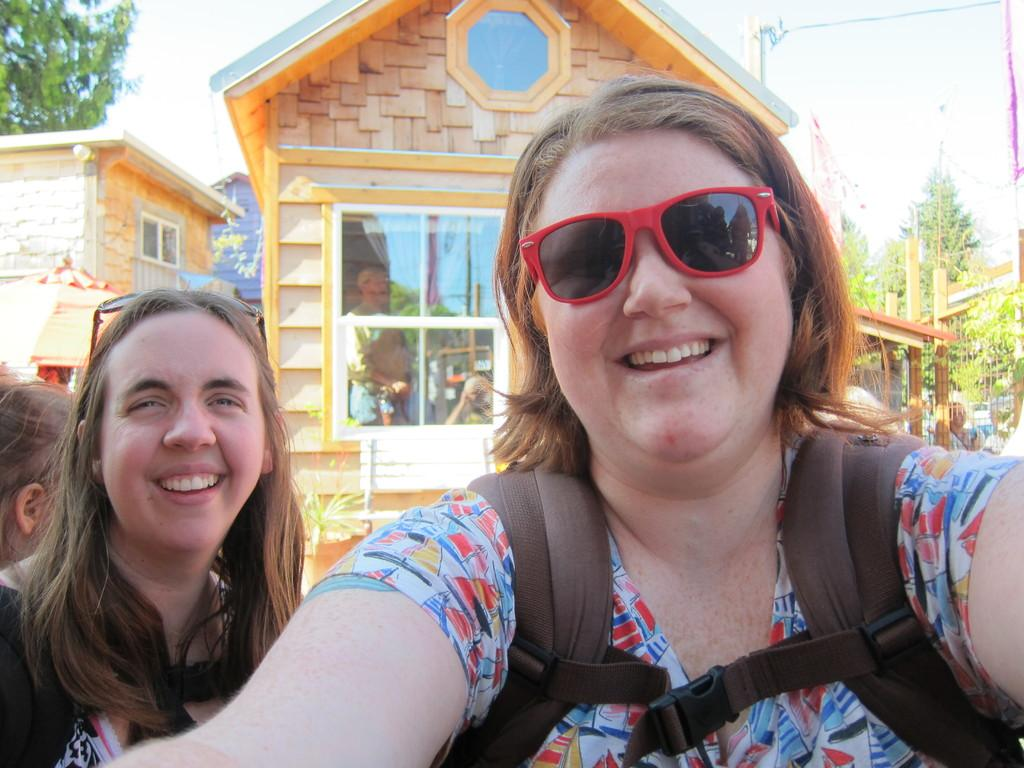Who is present in the image? There are ladies in the image. What is the facial expression of the ladies? The ladies are smiling. What can be seen in the background of the image? There are buildings and trees in the background of the image. What type of word can be seen in the image? There is no word present in the image; it features ladies and a background with buildings and trees. 